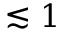<formula> <loc_0><loc_0><loc_500><loc_500>\lesssim 1</formula> 